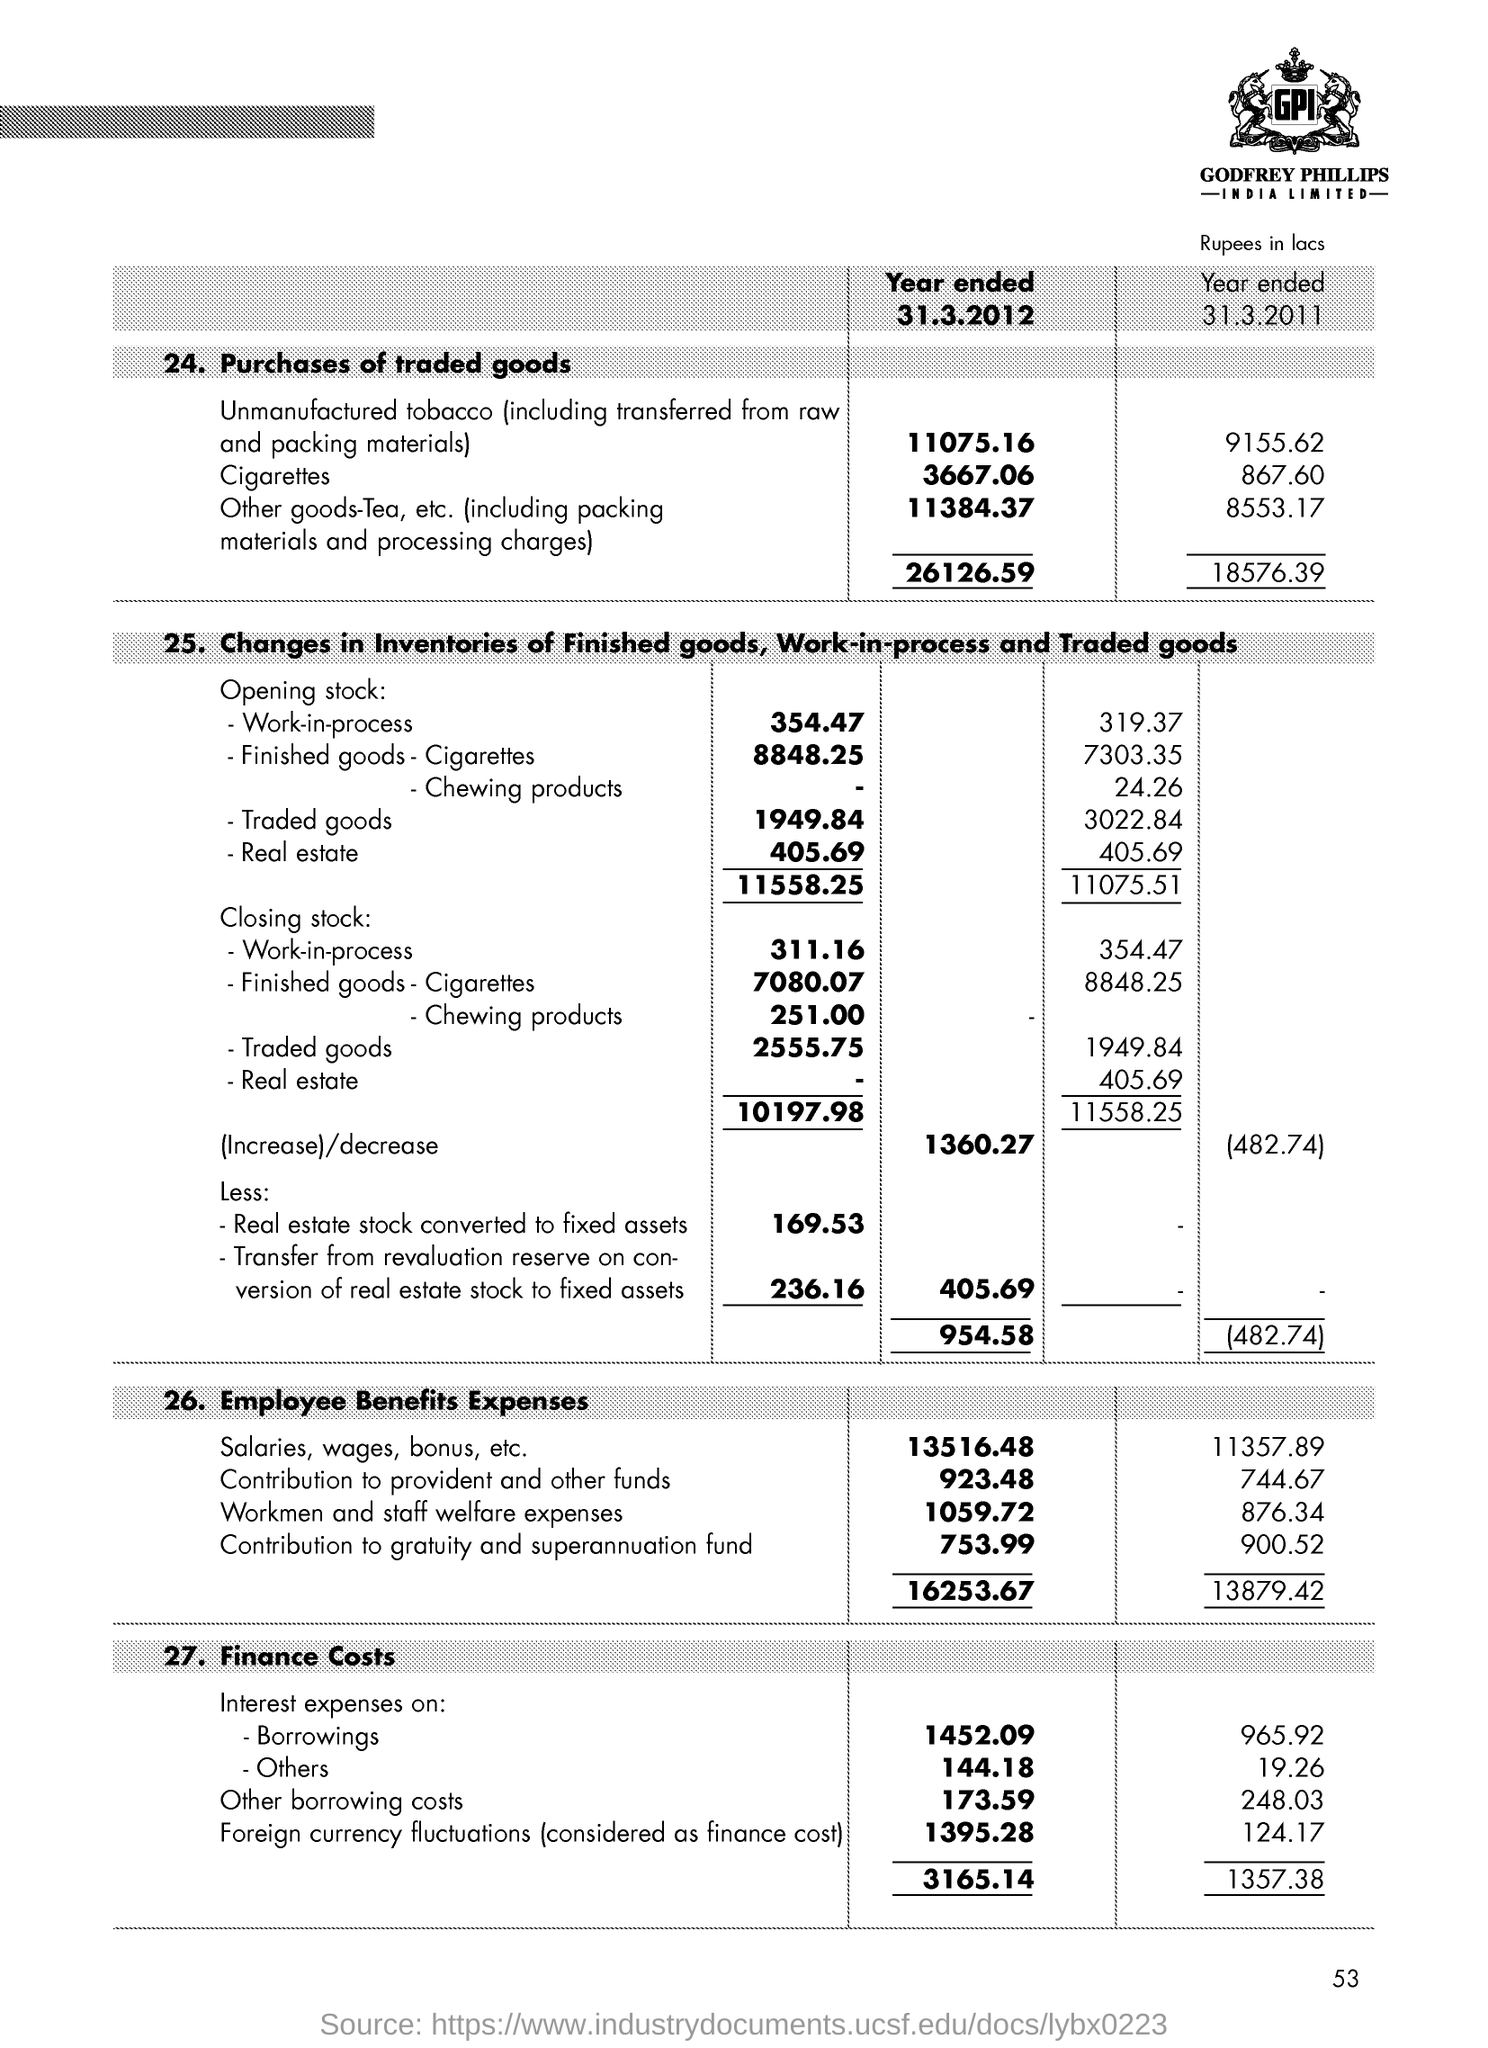Point out several critical features in this image. The finance cost for interest expenses on borrowings for the year ended March 31, 2012 was 1,452.09. The finance cost for interest expenses on others for the year ended March 31, 2012, was 144.18. The finance cost for interest expenses on others for the year ended March 31, 2011, was 19.26. 